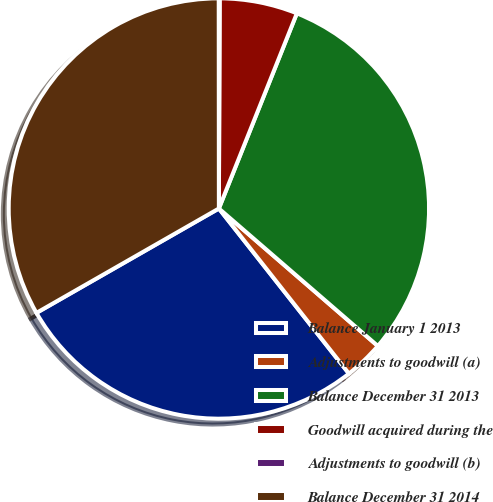Convert chart. <chart><loc_0><loc_0><loc_500><loc_500><pie_chart><fcel>Balance January 1 2013<fcel>Adjustments to goodwill (a)<fcel>Balance December 31 2013<fcel>Goodwill acquired during the<fcel>Adjustments to goodwill (b)<fcel>Balance December 31 2014<nl><fcel>27.35%<fcel>3.03%<fcel>30.3%<fcel>5.99%<fcel>0.07%<fcel>33.26%<nl></chart> 